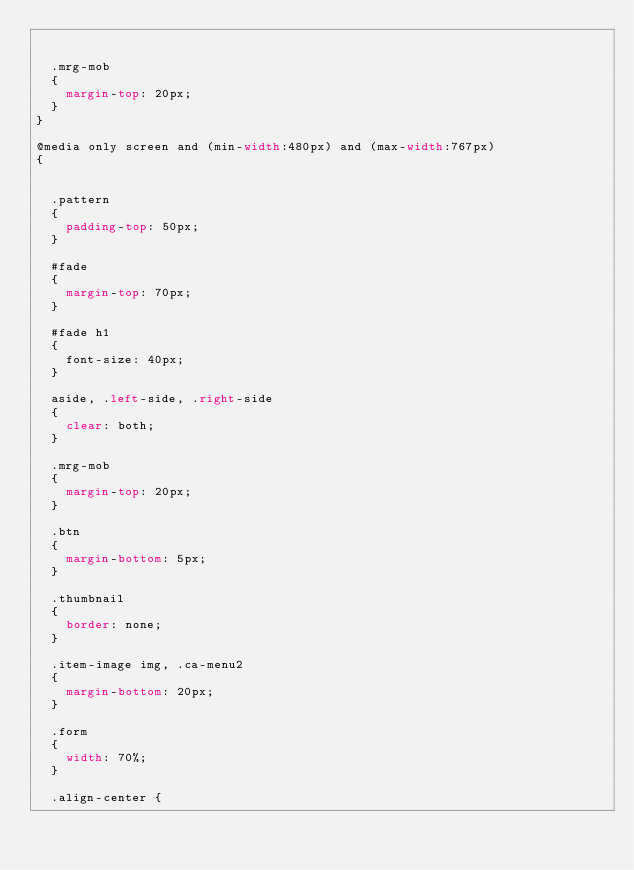<code> <loc_0><loc_0><loc_500><loc_500><_CSS_> 

  .mrg-mob
  {
    margin-top: 20px;
  }
}

@media only screen and (min-width:480px) and (max-width:767px)
{
 

  .pattern
  {
    padding-top: 50px;
  }

  #fade
  {
    margin-top: 70px;
  }

  #fade h1
  {
    font-size: 40px;
  }

  aside, .left-side, .right-side
  {
    clear: both;
  }

  .mrg-mob
  {
    margin-top: 20px;
  }

  .btn
  {
    margin-bottom: 5px;
  }

  .thumbnail
  {
    border: none;
  }

  .item-image img, .ca-menu2
  {
    margin-bottom: 20px;
  }

  .form
  {
    width: 70%;
  }
  
  .align-center {</code> 